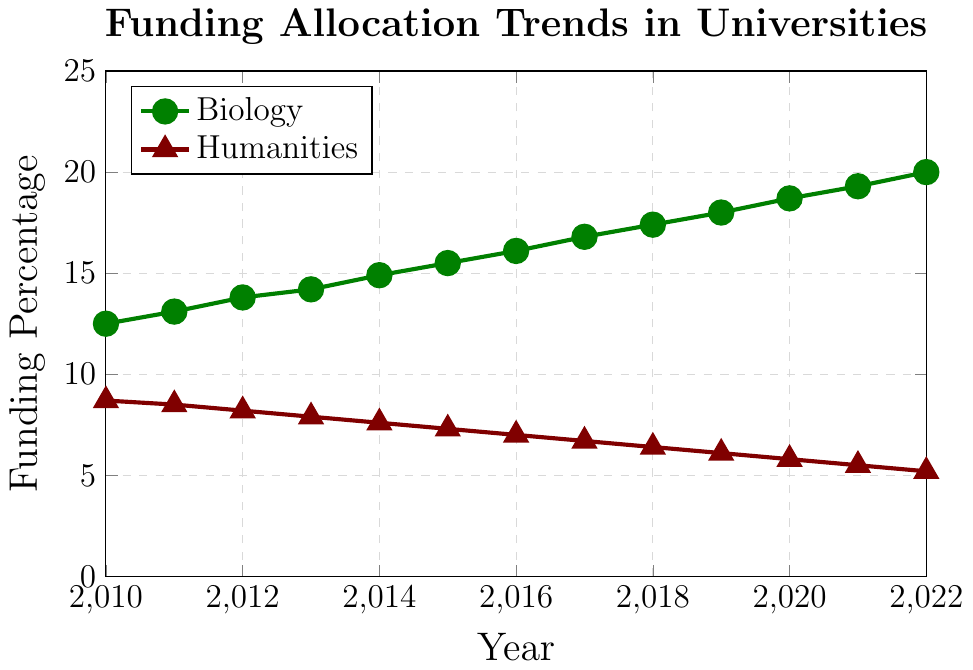Which department saw an increase in funding every year from 2010 to 2022? By examining the trend lines, we can see that the biology department's funding percentage increased every year, while the humanities department's funding percentage decreased every year over the same period.
Answer: Biology What is the percentage change in funding for the humanities department from 2010 to 2022? To find the percentage change, subtract the 2010 value from the 2022 value, divide by the 2010 value, and multiply by 100: ((5.2 - 8.7) / 8.7) * 100.
Answer: -40.2% In what year did the biology department's funding first exceed 15%? By examining the plot, we see that the biology department's funding first exceeds 15% in the year 2015.
Answer: 2015 How much more funding did the biology department receive compared to the humanities department in 2022? Subtract the humanities department's funding percentage from the biology department's funding percentage for 2022: 20.0 - 5.2.
Answer: 14.8% Which department had a more stable funding trend, and how can you tell? The humanities department had a more stable funding trend because its line is almost linear and consistently downward, while the biology department's line shows a steady and consistent increase.
Answer: Humanities In which year was the difference in funding between the two departments the smallest, and what was that difference? The smallest difference occurred in 2010, with biology at 12.5% and humanities at 8.7%, making the difference 12.5 - 8.7 = 3.8%.
Answer: 2010, 3.8% Calculate the average annual increment in funding for the biology department between 2010 and 2022. Calculate the total increment (20.0 - 12.5) and divide by the number of years (2022-2010): (20.0 - 12.5) / (2022 - 2010) = 7.5 / 12.
Answer: 0.625% What visual attributes differentiate the funding trends for biology and humanities in the chart? The biology department's funding is represented by a green line with circular markers, while the humanities department's funding is represented by a red line with triangular markers.
Answer: Color and marker shape Which year did the humanities department experience the largest absolute drop in funding percentage from the previous year? Observing the plot, the largest drop year-over-year is from 2010 to 2011, where funding decreased from 8.7% to 8.5%, a drop of 0.2%.
Answer: 2010 to 2011, 0.2% 